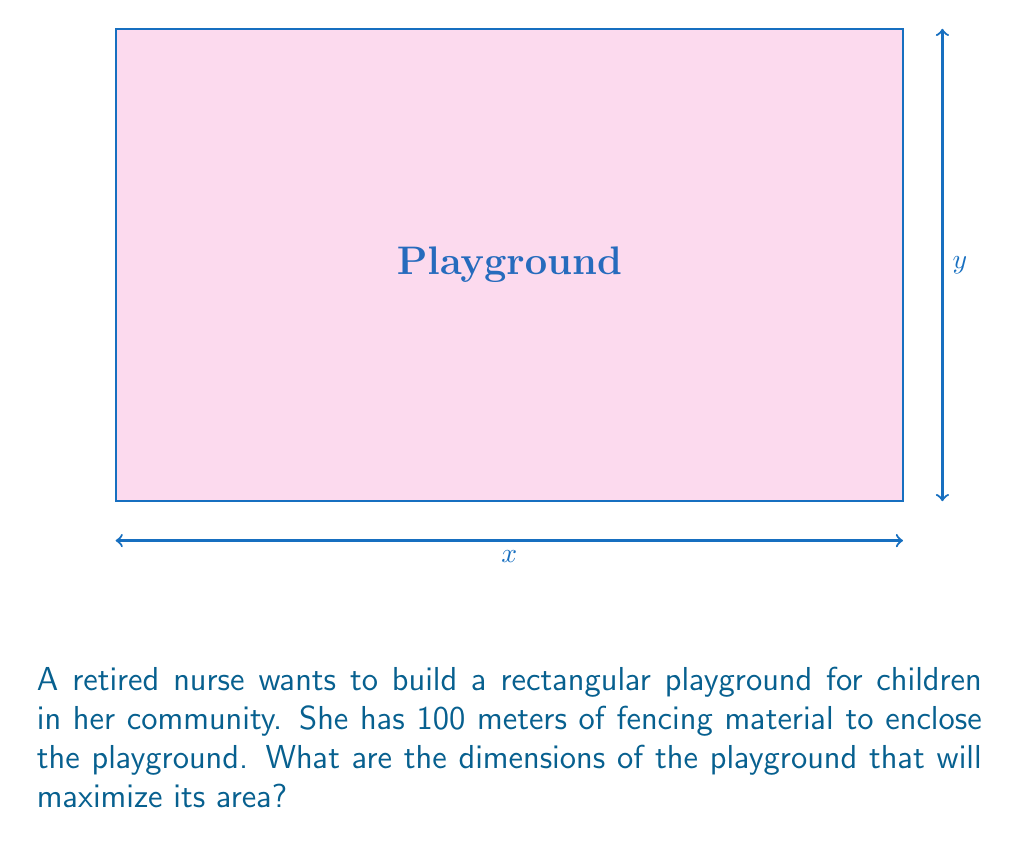Help me with this question. Let's approach this step-by-step:

1) Let $x$ be the length and $y$ be the width of the playground.

2) The perimeter of the rectangle is given as 100 meters:
   $$2x + 2y = 100$$

3) Solve this equation for $y$:
   $$y = 50 - x$$

4) The area of the rectangle is given by:
   $$A = xy$$

5) Substitute $y$ with $(50-x)$:
   $$A = x(50-x) = 50x - x^2$$

6) To find the maximum area, we need to find the derivative of $A$ with respect to $x$ and set it to zero:
   $$\frac{dA}{dx} = 50 - 2x$$

7) Set this equal to zero and solve for $x$:
   $$50 - 2x = 0$$
   $$2x = 50$$
   $$x = 25$$

8) Since the second derivative $\frac{d^2A}{dx^2} = -2$ is negative, this critical point is a maximum.

9) Calculate $y$:
   $$y = 50 - x = 50 - 25 = 25$$

10) Therefore, the dimensions that maximize the area are 25 meters by 25 meters.

11) The maximum area is:
    $$A = 25 * 25 = 625$$ square meters
Answer: 25 m × 25 m, 625 m² 